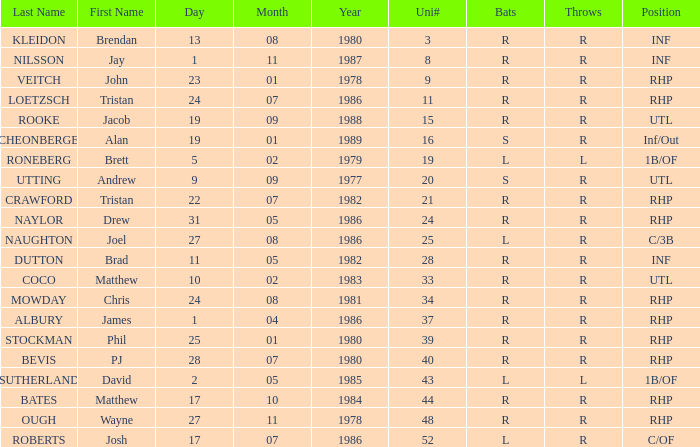Which Position has a Surname of naylor? RHP. 